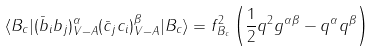Convert formula to latex. <formula><loc_0><loc_0><loc_500><loc_500>\langle B _ { c } | ( \bar { b } _ { i } b _ { j } ) ^ { \alpha } _ { V - A } ( \bar { c } _ { j } c _ { i } ) ^ { \beta } _ { V - A } | B _ { c } \rangle = f ^ { 2 } _ { B _ { c } } \left ( \frac { 1 } { 2 } q ^ { 2 } g ^ { \alpha \beta } - q ^ { \alpha } q ^ { \beta } \right )</formula> 